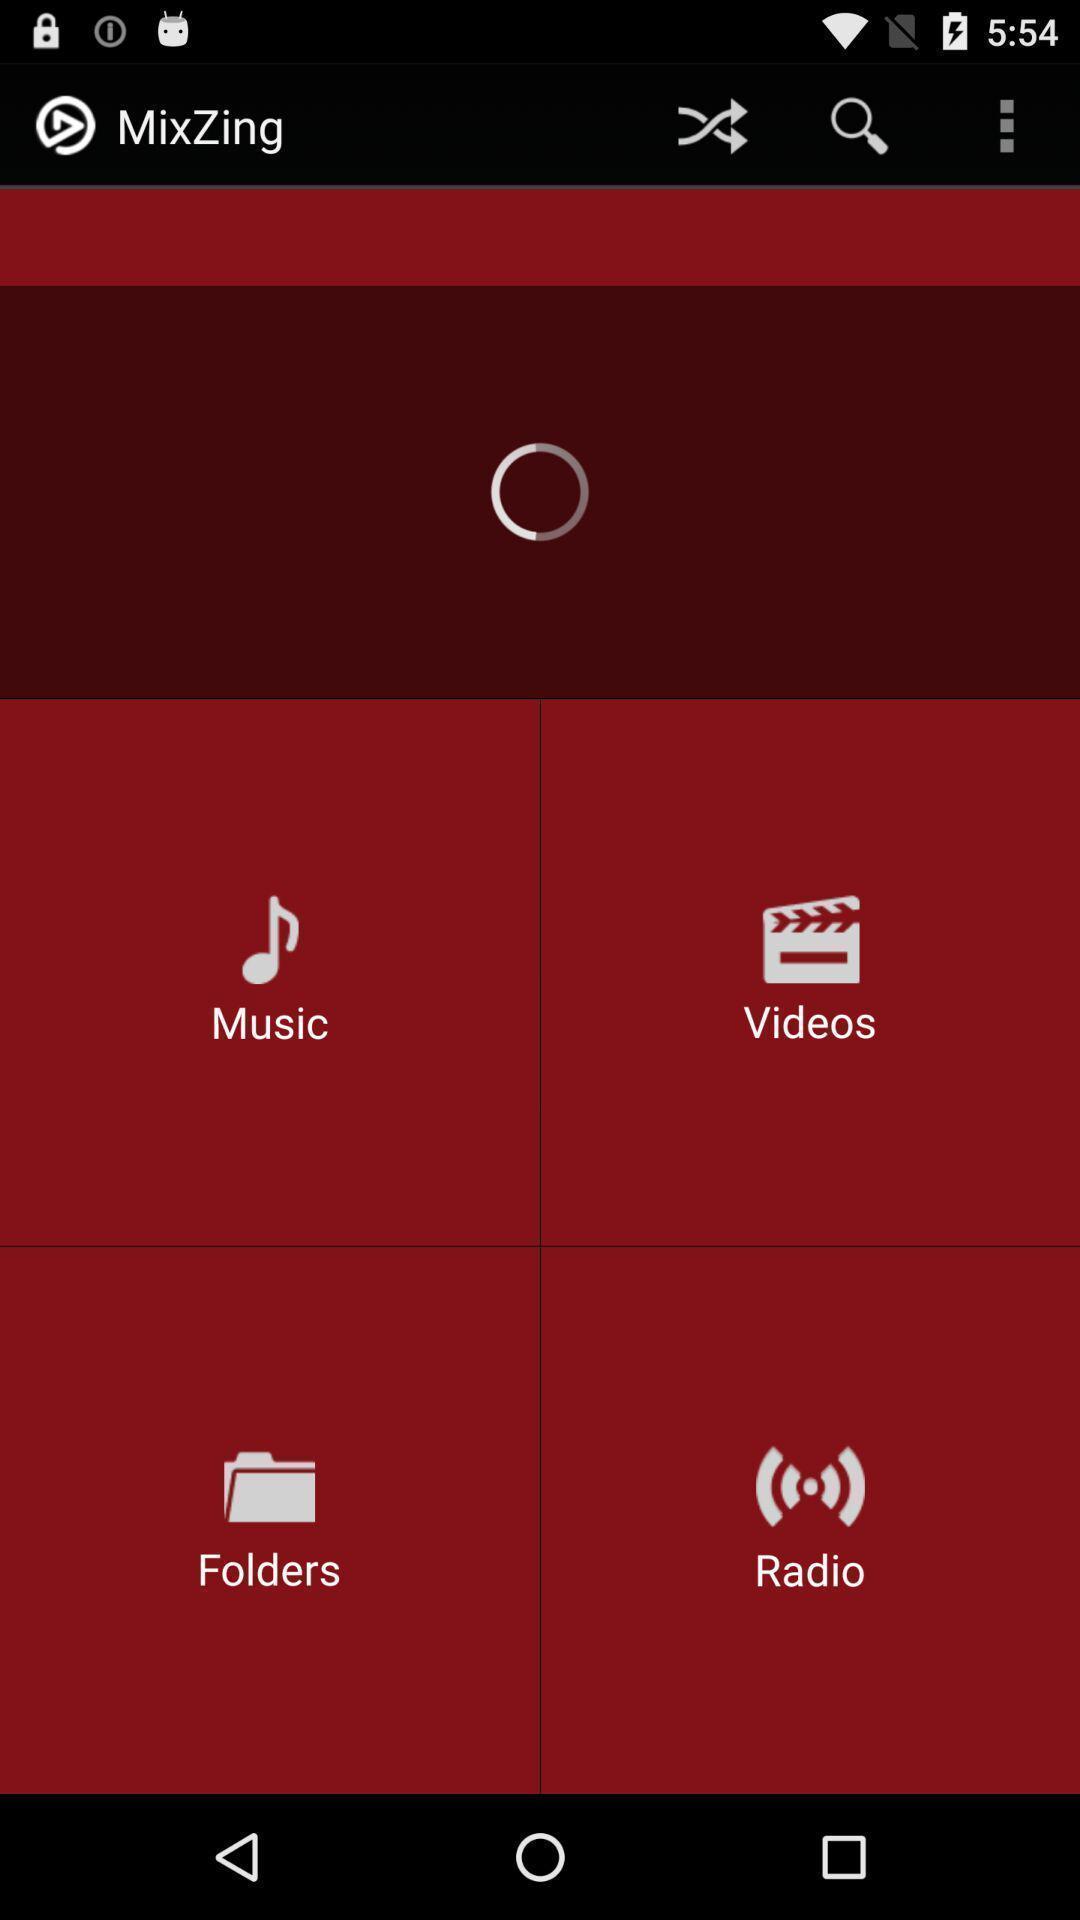What can you discern from this picture? Page displaying the options of a music app. 